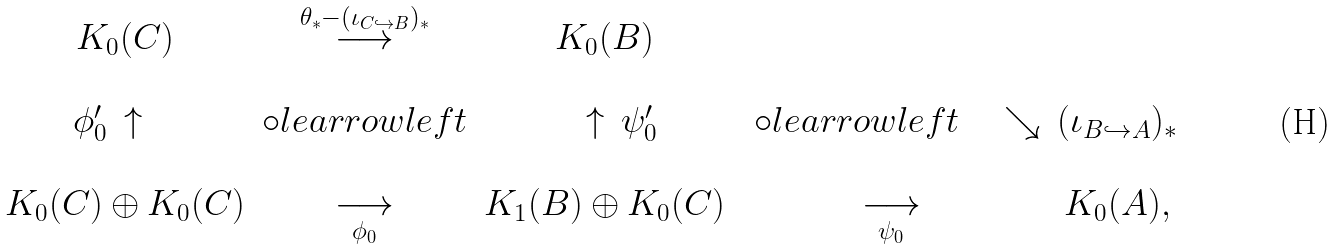<formula> <loc_0><loc_0><loc_500><loc_500>\begin{matrix} K _ { 0 } ( C ) & \overset { \theta _ { * } - ( \iota _ { C \hookrightarrow B } ) _ { * } } { \longrightarrow } & K _ { 0 } ( B ) \\ \\ \phi ^ { \prime } _ { 0 } \, \uparrow \quad & \circ l e a r r o w l e f t & \quad \uparrow \, \psi ^ { \prime } _ { 0 } & \ \circ l e a r r o w l e f t \quad \searrow & ( \iota _ { B \hookrightarrow A } ) _ { * } \\ \\ K _ { 0 } ( C ) \oplus K _ { 0 } ( C ) & \underset { \phi _ { 0 } } { \longrightarrow } & K _ { 1 } ( B ) \oplus K _ { 0 } ( C ) & \underset { \psi _ { 0 } } { \longrightarrow } & K _ { 0 } ( A ) , \\ \end{matrix}</formula> 